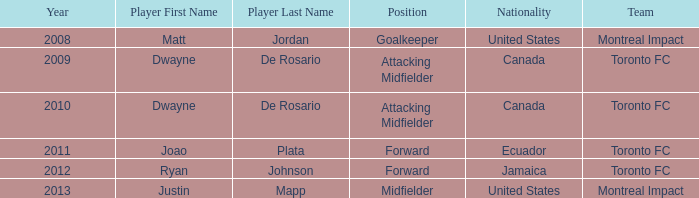What's the position when the player was Justin Mapp Category:articles with hcards with a United States nationality? Midfielder. 